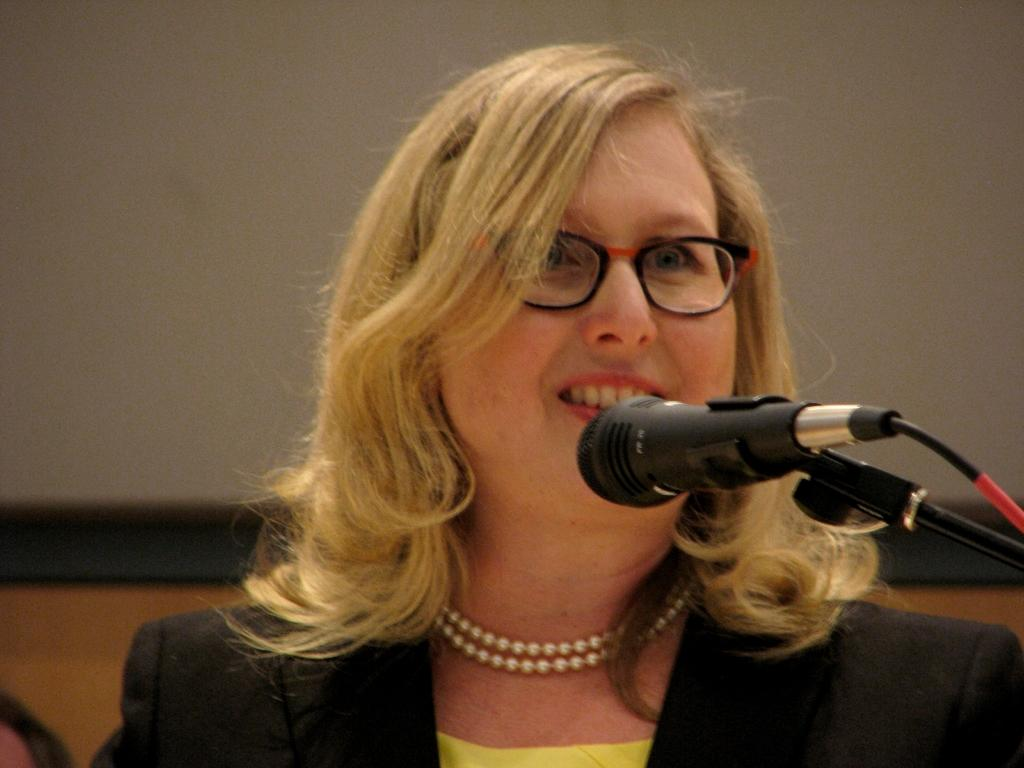Who is present in the image? There is a woman in the image. What is the woman doing in the image? The woman is smiling in the image. What object is on the right side of the image? There is a microphone with a stand on the right side of the image. What can be seen in the background of the image? There is a board in the background of the image. What type of poison is being used to extinguish the flame in the image? There is no flame or poison present in the image. 